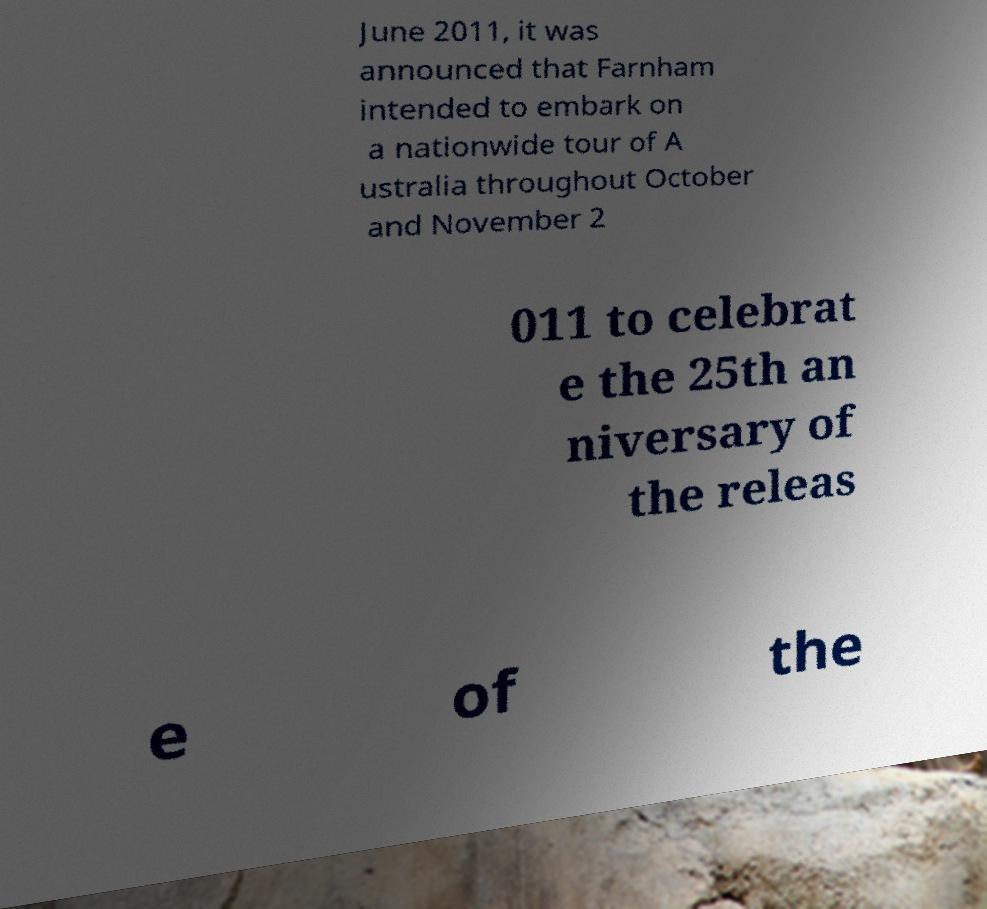Could you assist in decoding the text presented in this image and type it out clearly? June 2011, it was announced that Farnham intended to embark on a nationwide tour of A ustralia throughout October and November 2 011 to celebrat e the 25th an niversary of the releas e of the 